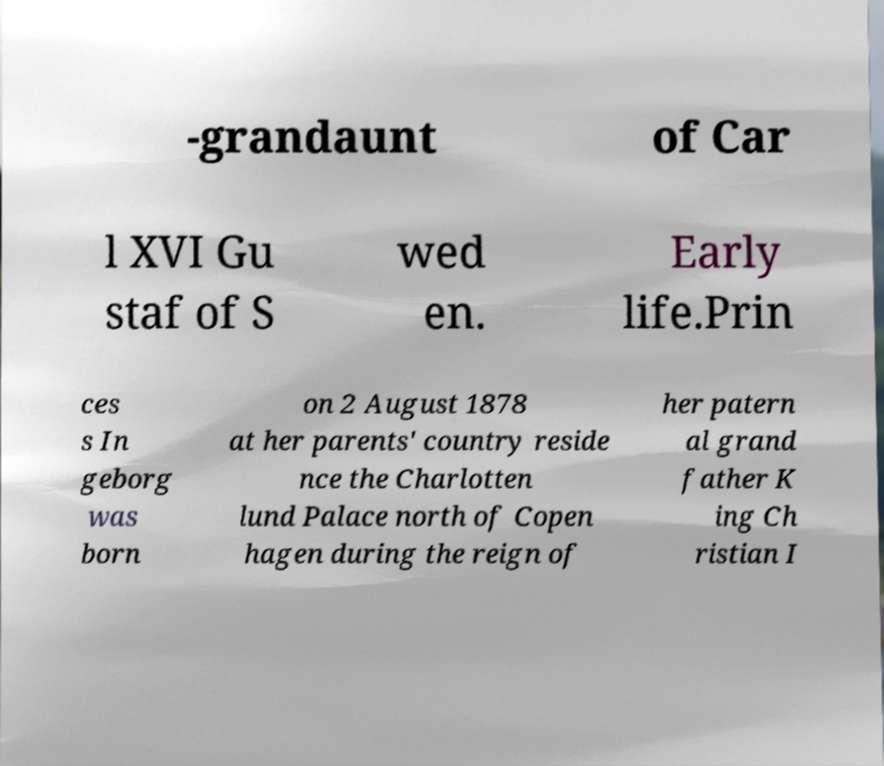Please read and relay the text visible in this image. What does it say? -grandaunt of Car l XVI Gu staf of S wed en. Early life.Prin ces s In geborg was born on 2 August 1878 at her parents' country reside nce the Charlotten lund Palace north of Copen hagen during the reign of her patern al grand father K ing Ch ristian I 